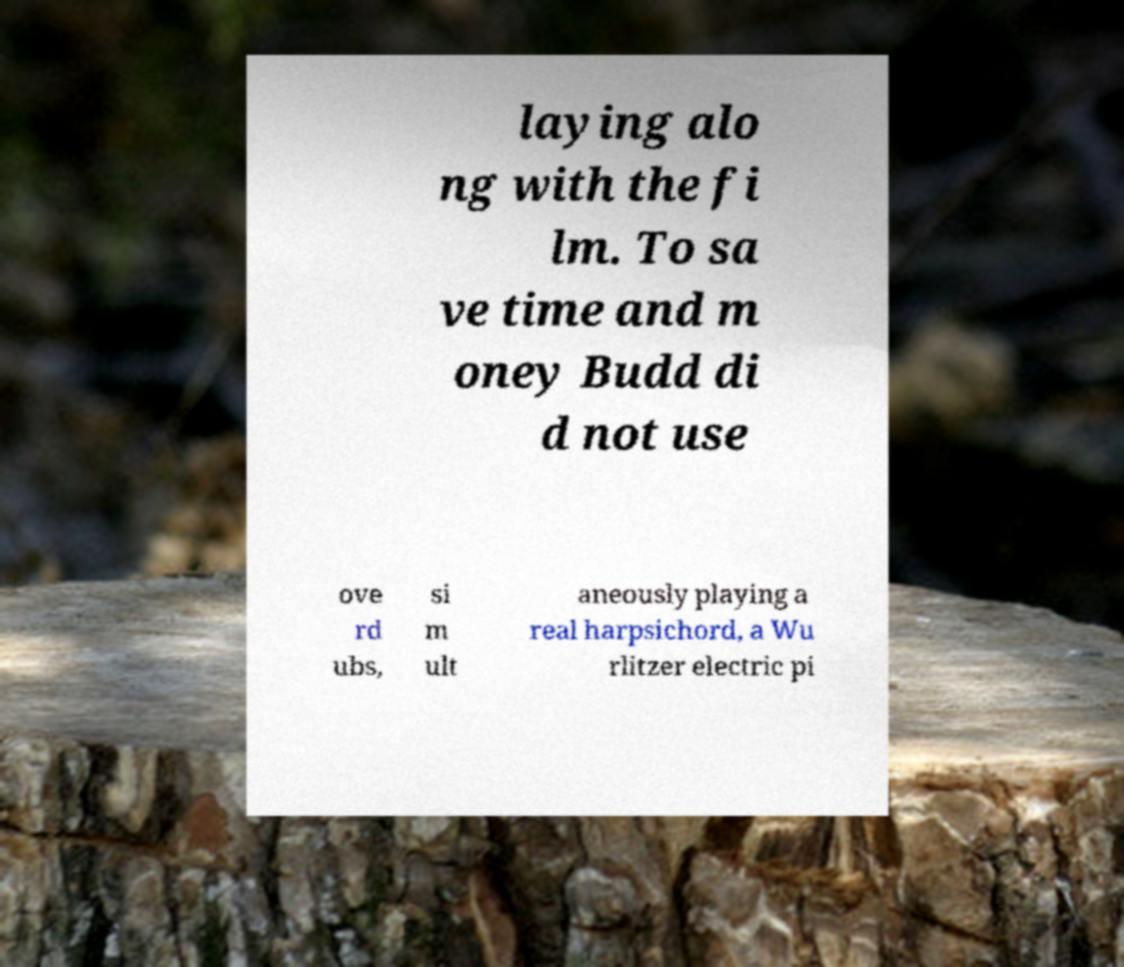Please identify and transcribe the text found in this image. laying alo ng with the fi lm. To sa ve time and m oney Budd di d not use ove rd ubs, si m ult aneously playing a real harpsichord, a Wu rlitzer electric pi 